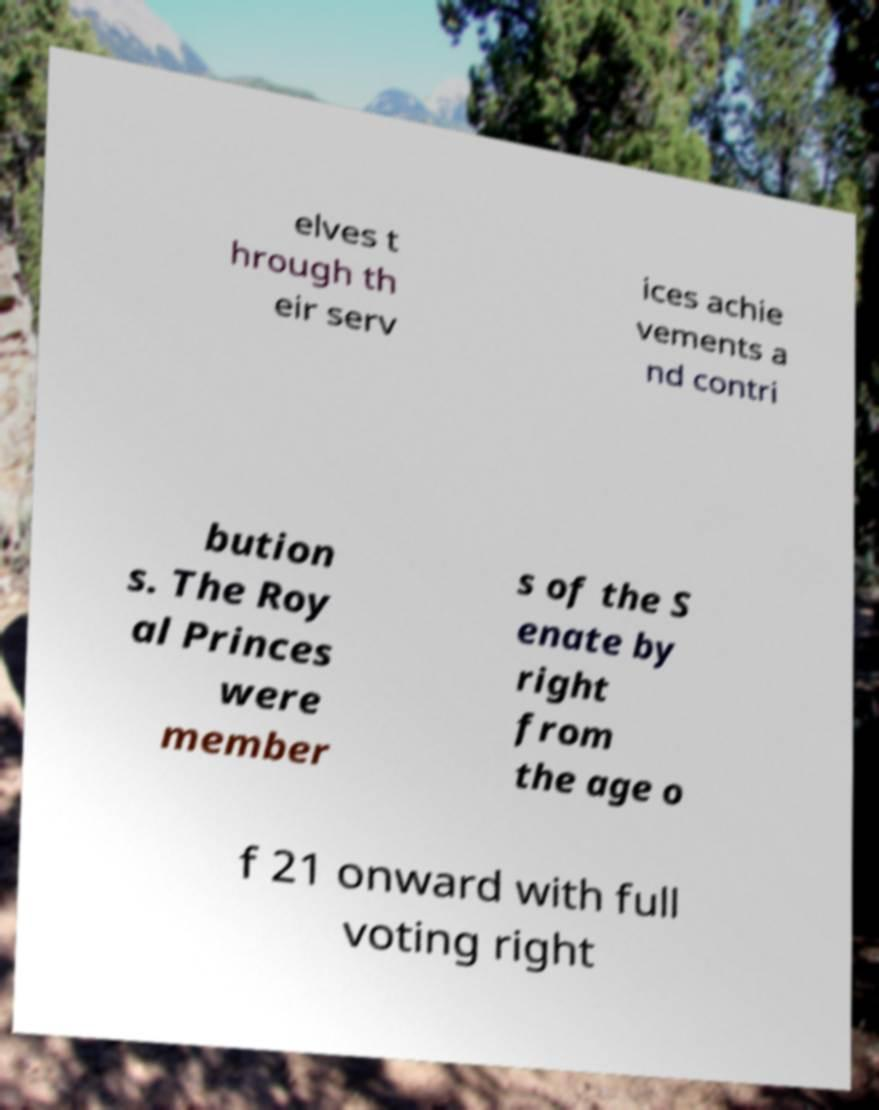There's text embedded in this image that I need extracted. Can you transcribe it verbatim? elves t hrough th eir serv ices achie vements a nd contri bution s. The Roy al Princes were member s of the S enate by right from the age o f 21 onward with full voting right 